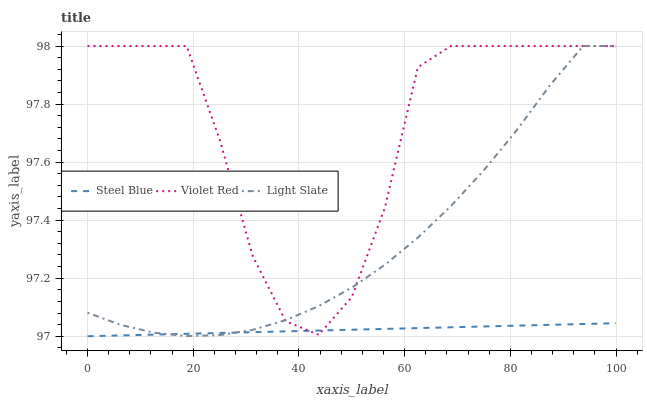Does Steel Blue have the minimum area under the curve?
Answer yes or no. Yes. Does Violet Red have the maximum area under the curve?
Answer yes or no. Yes. Does Violet Red have the minimum area under the curve?
Answer yes or no. No. Does Steel Blue have the maximum area under the curve?
Answer yes or no. No. Is Steel Blue the smoothest?
Answer yes or no. Yes. Is Violet Red the roughest?
Answer yes or no. Yes. Is Violet Red the smoothest?
Answer yes or no. No. Is Steel Blue the roughest?
Answer yes or no. No. Does Violet Red have the lowest value?
Answer yes or no. No. Does Steel Blue have the highest value?
Answer yes or no. No. 